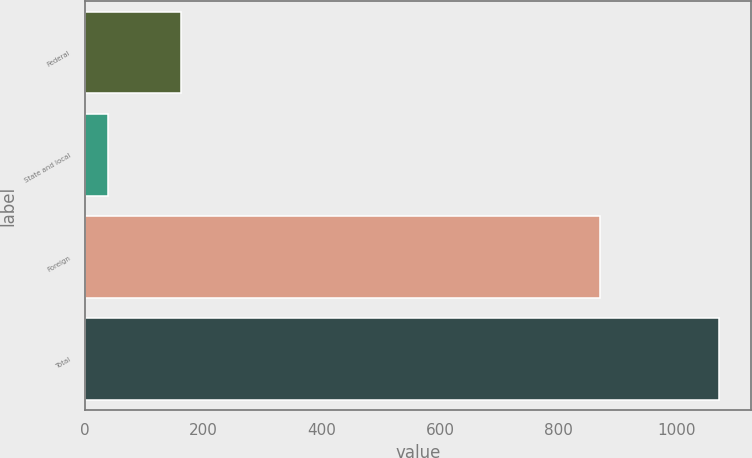Convert chart to OTSL. <chart><loc_0><loc_0><loc_500><loc_500><bar_chart><fcel>Federal<fcel>State and local<fcel>Foreign<fcel>Total<nl><fcel>162<fcel>40<fcel>870<fcel>1072<nl></chart> 